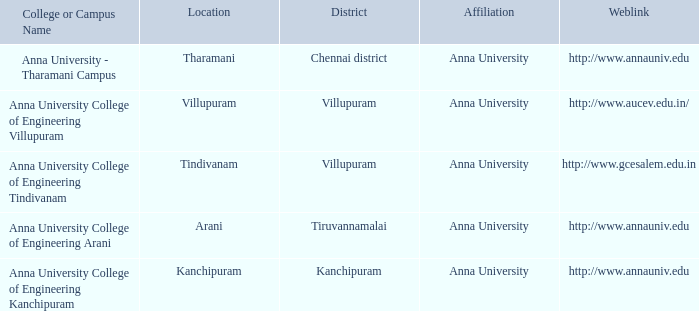What District has a Location of villupuram? Villupuram. Parse the full table. {'header': ['College or Campus Name', 'Location', 'District', 'Affiliation', 'Weblink'], 'rows': [['Anna University - Tharamani Campus', 'Tharamani', 'Chennai district', 'Anna University', 'http://www.annauniv.edu'], ['Anna University College of Engineering Villupuram', 'Villupuram', 'Villupuram', 'Anna University', 'http://www.aucev.edu.in/'], ['Anna University College of Engineering Tindivanam', 'Tindivanam', 'Villupuram', 'Anna University', 'http://www.gcesalem.edu.in'], ['Anna University College of Engineering Arani', 'Arani', 'Tiruvannamalai', 'Anna University', 'http://www.annauniv.edu'], ['Anna University College of Engineering Kanchipuram', 'Kanchipuram', 'Kanchipuram', 'Anna University', 'http://www.annauniv.edu']]} 